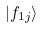<formula> <loc_0><loc_0><loc_500><loc_500>| f _ { 1 j } \rangle</formula> 